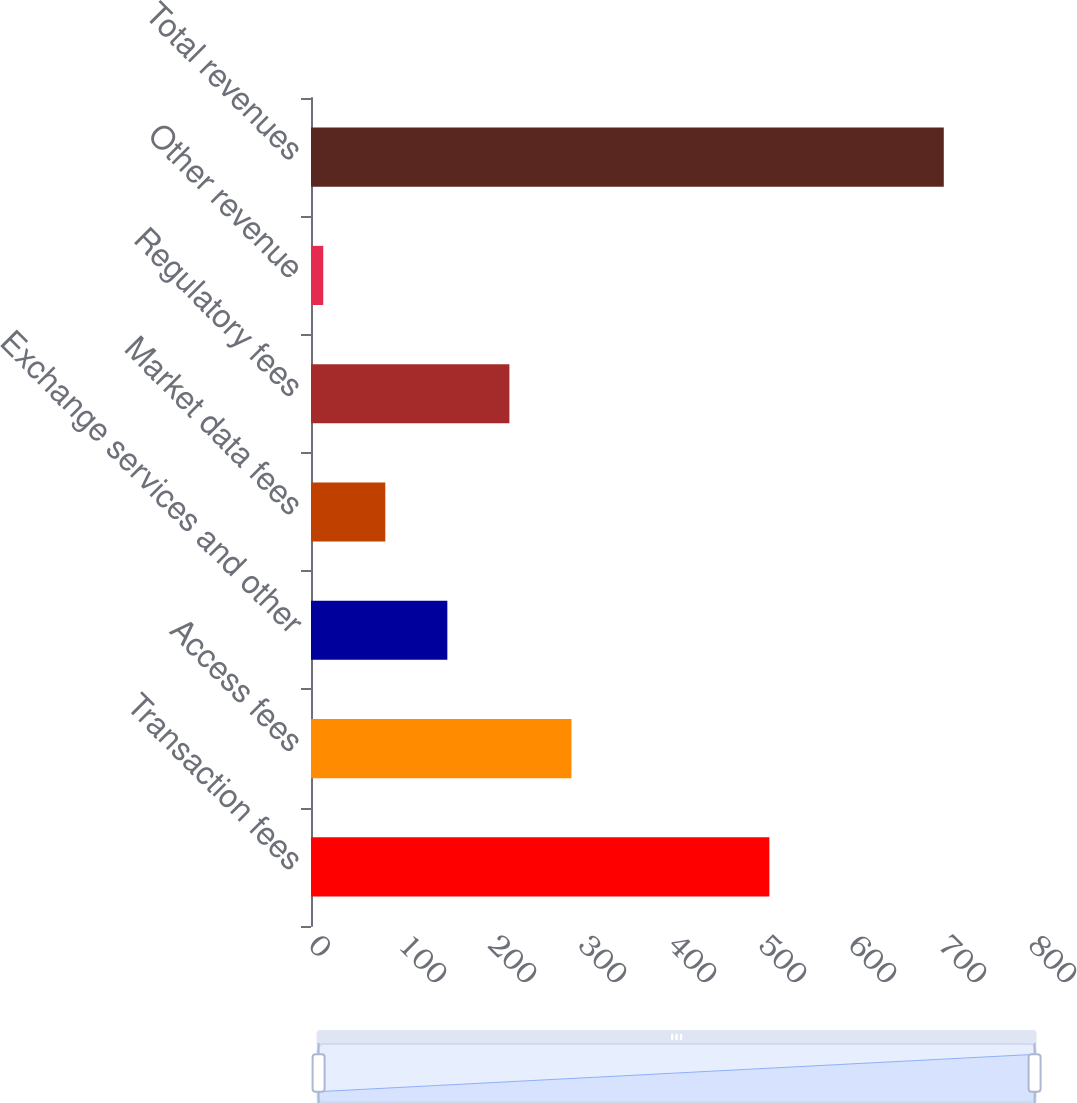Convert chart to OTSL. <chart><loc_0><loc_0><loc_500><loc_500><bar_chart><fcel>Transaction fees<fcel>Access fees<fcel>Exchange services and other<fcel>Market data fees<fcel>Regulatory fees<fcel>Other revenue<fcel>Total revenues<nl><fcel>509.3<fcel>289.4<fcel>151.5<fcel>82.55<fcel>220.45<fcel>13.6<fcel>703.1<nl></chart> 